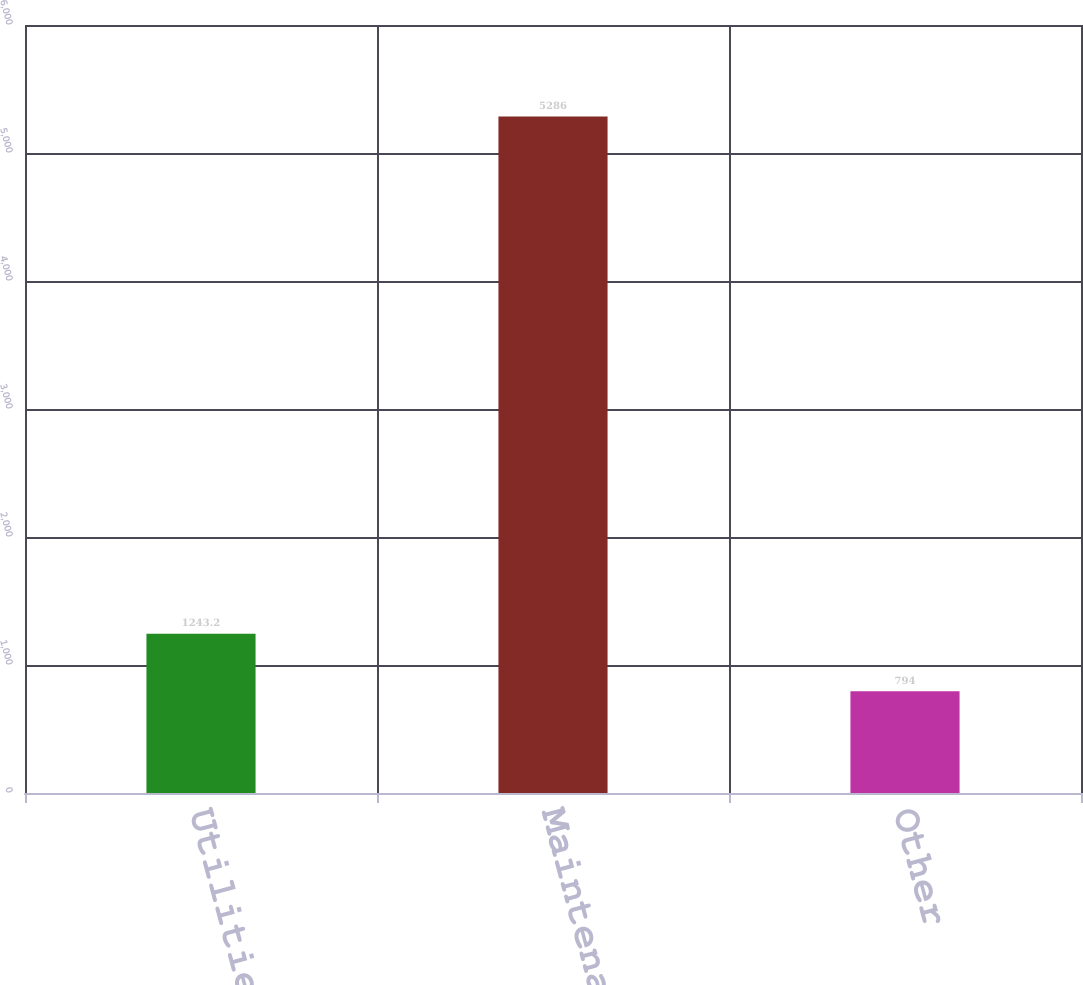Convert chart to OTSL. <chart><loc_0><loc_0><loc_500><loc_500><bar_chart><fcel>Utilities<fcel>Maintenance<fcel>Other<nl><fcel>1243.2<fcel>5286<fcel>794<nl></chart> 